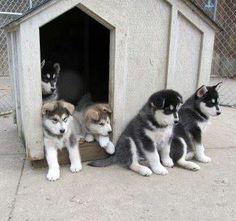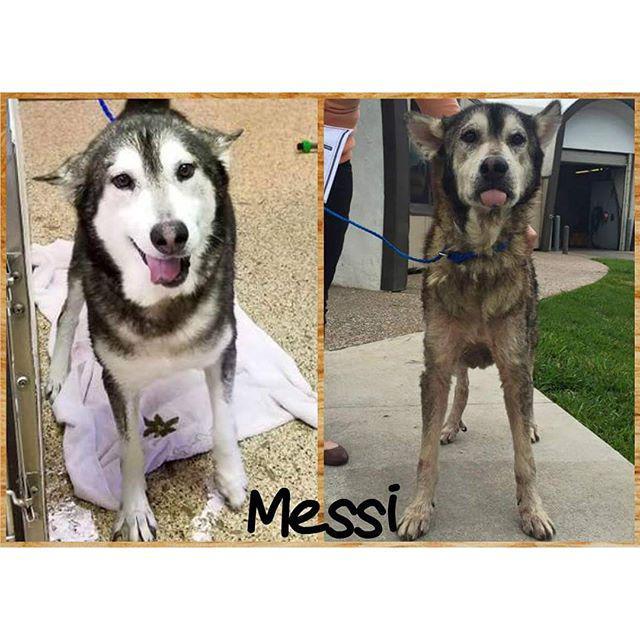The first image is the image on the left, the second image is the image on the right. For the images shown, is this caption "The right image shows a husky dog perched atop a rectangular table in front of something with criss-crossing lines." true? Answer yes or no. No. The first image is the image on the left, the second image is the image on the right. Examine the images to the left and right. Is the description "There is at least one dog on top of a table." accurate? Answer yes or no. No. 